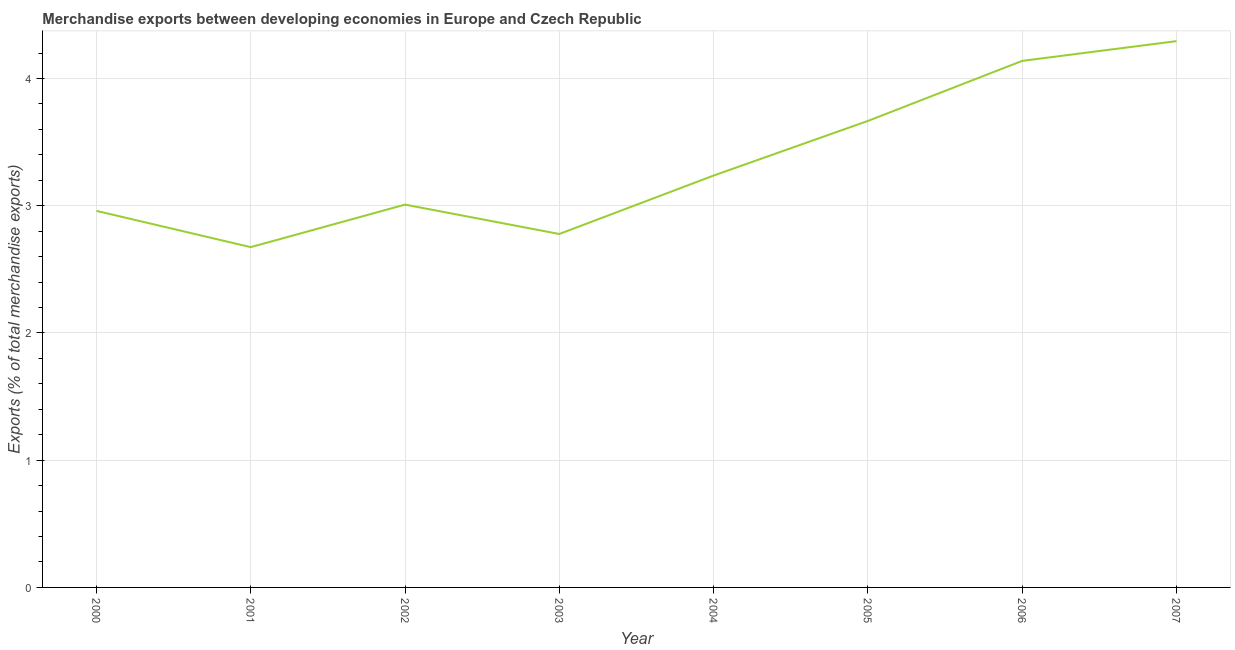What is the merchandise exports in 2007?
Give a very brief answer. 4.29. Across all years, what is the maximum merchandise exports?
Provide a succinct answer. 4.29. Across all years, what is the minimum merchandise exports?
Offer a terse response. 2.67. What is the sum of the merchandise exports?
Offer a terse response. 26.76. What is the difference between the merchandise exports in 2000 and 2003?
Offer a terse response. 0.18. What is the average merchandise exports per year?
Ensure brevity in your answer.  3.34. What is the median merchandise exports?
Make the answer very short. 3.12. What is the ratio of the merchandise exports in 2003 to that in 2007?
Your answer should be very brief. 0.65. Is the merchandise exports in 2000 less than that in 2002?
Offer a very short reply. Yes. Is the difference between the merchandise exports in 2003 and 2005 greater than the difference between any two years?
Make the answer very short. No. What is the difference between the highest and the second highest merchandise exports?
Provide a short and direct response. 0.16. What is the difference between the highest and the lowest merchandise exports?
Keep it short and to the point. 1.62. In how many years, is the merchandise exports greater than the average merchandise exports taken over all years?
Your response must be concise. 3. How many years are there in the graph?
Your answer should be compact. 8. What is the difference between two consecutive major ticks on the Y-axis?
Your answer should be compact. 1. Does the graph contain any zero values?
Your response must be concise. No. What is the title of the graph?
Your answer should be compact. Merchandise exports between developing economies in Europe and Czech Republic. What is the label or title of the Y-axis?
Make the answer very short. Exports (% of total merchandise exports). What is the Exports (% of total merchandise exports) in 2000?
Give a very brief answer. 2.96. What is the Exports (% of total merchandise exports) in 2001?
Your response must be concise. 2.67. What is the Exports (% of total merchandise exports) of 2002?
Your response must be concise. 3.01. What is the Exports (% of total merchandise exports) of 2003?
Make the answer very short. 2.78. What is the Exports (% of total merchandise exports) in 2004?
Offer a very short reply. 3.24. What is the Exports (% of total merchandise exports) in 2005?
Ensure brevity in your answer.  3.67. What is the Exports (% of total merchandise exports) in 2006?
Provide a succinct answer. 4.14. What is the Exports (% of total merchandise exports) in 2007?
Your answer should be compact. 4.29. What is the difference between the Exports (% of total merchandise exports) in 2000 and 2001?
Your answer should be very brief. 0.29. What is the difference between the Exports (% of total merchandise exports) in 2000 and 2002?
Your response must be concise. -0.05. What is the difference between the Exports (% of total merchandise exports) in 2000 and 2003?
Give a very brief answer. 0.18. What is the difference between the Exports (% of total merchandise exports) in 2000 and 2004?
Your answer should be compact. -0.28. What is the difference between the Exports (% of total merchandise exports) in 2000 and 2005?
Your response must be concise. -0.71. What is the difference between the Exports (% of total merchandise exports) in 2000 and 2006?
Ensure brevity in your answer.  -1.18. What is the difference between the Exports (% of total merchandise exports) in 2000 and 2007?
Keep it short and to the point. -1.33. What is the difference between the Exports (% of total merchandise exports) in 2001 and 2002?
Give a very brief answer. -0.33. What is the difference between the Exports (% of total merchandise exports) in 2001 and 2003?
Your answer should be compact. -0.1. What is the difference between the Exports (% of total merchandise exports) in 2001 and 2004?
Give a very brief answer. -0.56. What is the difference between the Exports (% of total merchandise exports) in 2001 and 2005?
Provide a succinct answer. -0.99. What is the difference between the Exports (% of total merchandise exports) in 2001 and 2006?
Offer a very short reply. -1.46. What is the difference between the Exports (% of total merchandise exports) in 2001 and 2007?
Keep it short and to the point. -1.62. What is the difference between the Exports (% of total merchandise exports) in 2002 and 2003?
Your answer should be compact. 0.23. What is the difference between the Exports (% of total merchandise exports) in 2002 and 2004?
Your response must be concise. -0.23. What is the difference between the Exports (% of total merchandise exports) in 2002 and 2005?
Your answer should be very brief. -0.66. What is the difference between the Exports (% of total merchandise exports) in 2002 and 2006?
Your answer should be compact. -1.13. What is the difference between the Exports (% of total merchandise exports) in 2002 and 2007?
Make the answer very short. -1.28. What is the difference between the Exports (% of total merchandise exports) in 2003 and 2004?
Offer a very short reply. -0.46. What is the difference between the Exports (% of total merchandise exports) in 2003 and 2005?
Keep it short and to the point. -0.89. What is the difference between the Exports (% of total merchandise exports) in 2003 and 2006?
Give a very brief answer. -1.36. What is the difference between the Exports (% of total merchandise exports) in 2003 and 2007?
Make the answer very short. -1.52. What is the difference between the Exports (% of total merchandise exports) in 2004 and 2005?
Your answer should be compact. -0.43. What is the difference between the Exports (% of total merchandise exports) in 2004 and 2006?
Provide a short and direct response. -0.9. What is the difference between the Exports (% of total merchandise exports) in 2004 and 2007?
Your answer should be compact. -1.06. What is the difference between the Exports (% of total merchandise exports) in 2005 and 2006?
Offer a terse response. -0.47. What is the difference between the Exports (% of total merchandise exports) in 2005 and 2007?
Offer a very short reply. -0.63. What is the difference between the Exports (% of total merchandise exports) in 2006 and 2007?
Your response must be concise. -0.16. What is the ratio of the Exports (% of total merchandise exports) in 2000 to that in 2001?
Ensure brevity in your answer.  1.11. What is the ratio of the Exports (% of total merchandise exports) in 2000 to that in 2003?
Provide a short and direct response. 1.06. What is the ratio of the Exports (% of total merchandise exports) in 2000 to that in 2004?
Offer a terse response. 0.91. What is the ratio of the Exports (% of total merchandise exports) in 2000 to that in 2005?
Offer a terse response. 0.81. What is the ratio of the Exports (% of total merchandise exports) in 2000 to that in 2006?
Make the answer very short. 0.71. What is the ratio of the Exports (% of total merchandise exports) in 2000 to that in 2007?
Your response must be concise. 0.69. What is the ratio of the Exports (% of total merchandise exports) in 2001 to that in 2002?
Make the answer very short. 0.89. What is the ratio of the Exports (% of total merchandise exports) in 2001 to that in 2004?
Provide a succinct answer. 0.83. What is the ratio of the Exports (% of total merchandise exports) in 2001 to that in 2005?
Make the answer very short. 0.73. What is the ratio of the Exports (% of total merchandise exports) in 2001 to that in 2006?
Provide a succinct answer. 0.65. What is the ratio of the Exports (% of total merchandise exports) in 2001 to that in 2007?
Provide a succinct answer. 0.62. What is the ratio of the Exports (% of total merchandise exports) in 2002 to that in 2003?
Your answer should be very brief. 1.08. What is the ratio of the Exports (% of total merchandise exports) in 2002 to that in 2004?
Provide a succinct answer. 0.93. What is the ratio of the Exports (% of total merchandise exports) in 2002 to that in 2005?
Provide a succinct answer. 0.82. What is the ratio of the Exports (% of total merchandise exports) in 2002 to that in 2006?
Offer a very short reply. 0.73. What is the ratio of the Exports (% of total merchandise exports) in 2002 to that in 2007?
Keep it short and to the point. 0.7. What is the ratio of the Exports (% of total merchandise exports) in 2003 to that in 2004?
Offer a terse response. 0.86. What is the ratio of the Exports (% of total merchandise exports) in 2003 to that in 2005?
Your response must be concise. 0.76. What is the ratio of the Exports (% of total merchandise exports) in 2003 to that in 2006?
Give a very brief answer. 0.67. What is the ratio of the Exports (% of total merchandise exports) in 2003 to that in 2007?
Provide a succinct answer. 0.65. What is the ratio of the Exports (% of total merchandise exports) in 2004 to that in 2005?
Your response must be concise. 0.88. What is the ratio of the Exports (% of total merchandise exports) in 2004 to that in 2006?
Offer a very short reply. 0.78. What is the ratio of the Exports (% of total merchandise exports) in 2004 to that in 2007?
Your answer should be very brief. 0.75. What is the ratio of the Exports (% of total merchandise exports) in 2005 to that in 2006?
Give a very brief answer. 0.89. What is the ratio of the Exports (% of total merchandise exports) in 2005 to that in 2007?
Your answer should be compact. 0.85. 